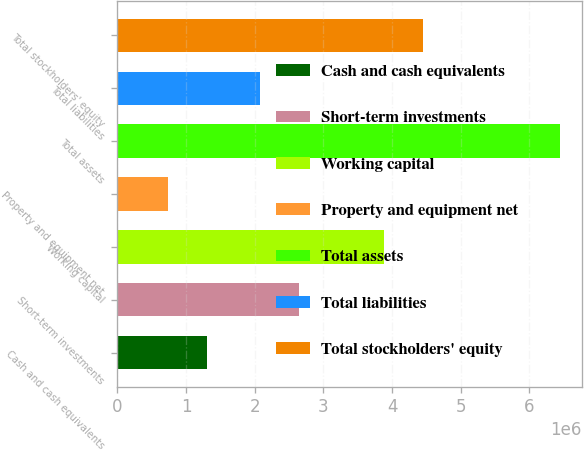<chart> <loc_0><loc_0><loc_500><loc_500><bar_chart><fcel>Cash and cash equivalents<fcel>Short-term investments<fcel>Working capital<fcel>Property and equipment net<fcel>Total assets<fcel>Total liabilities<fcel>Total stockholders' equity<nl><fcel>1.30601e+06<fcel>2.64511e+06<fcel>3.87575e+06<fcel>735299<fcel>6.44244e+06<fcel>2.07439e+06<fcel>4.44647e+06<nl></chart> 